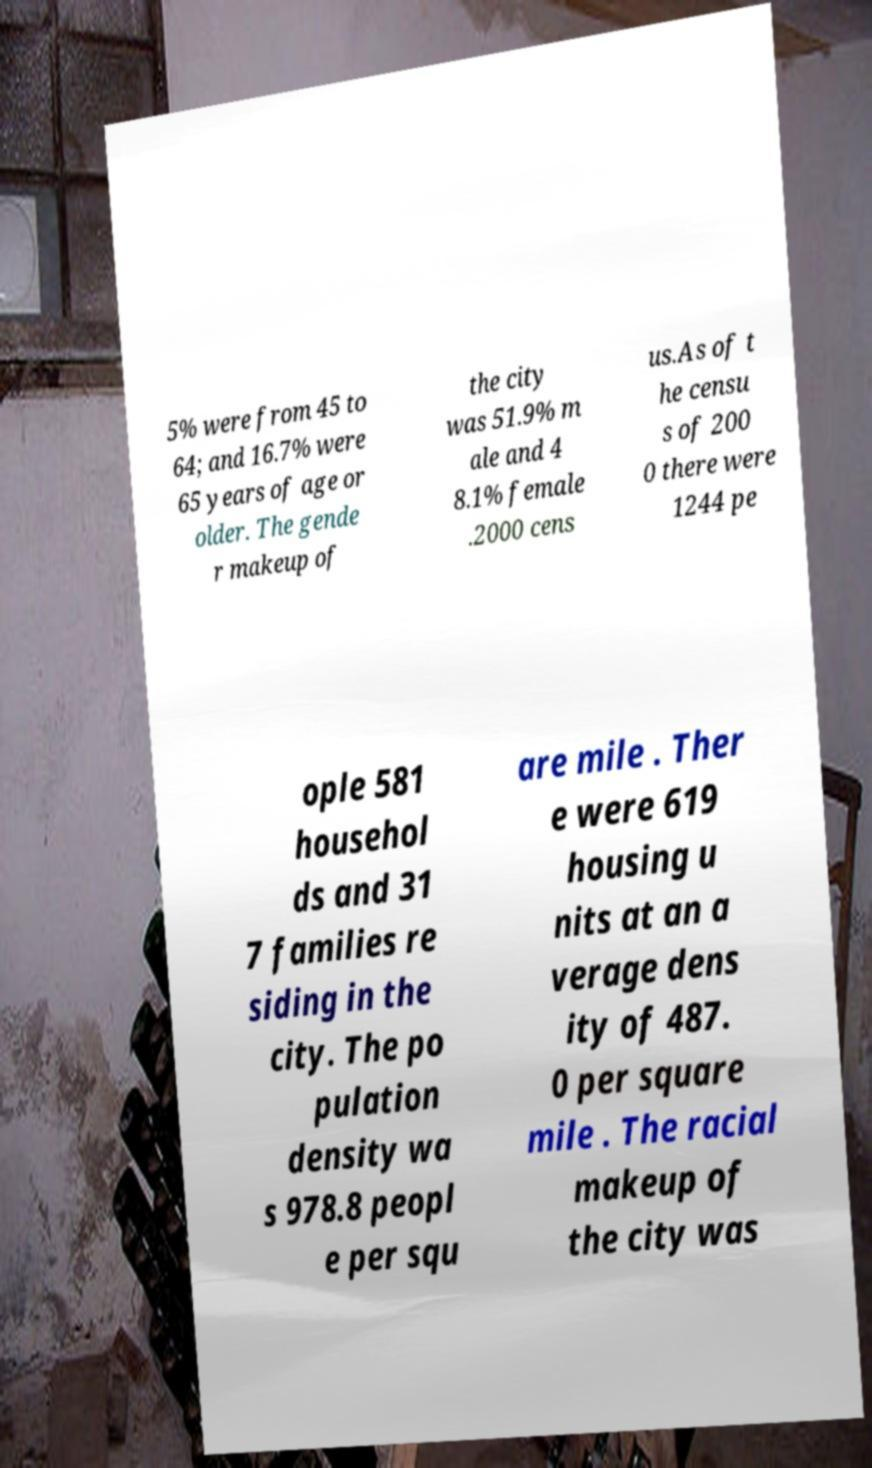Could you assist in decoding the text presented in this image and type it out clearly? 5% were from 45 to 64; and 16.7% were 65 years of age or older. The gende r makeup of the city was 51.9% m ale and 4 8.1% female .2000 cens us.As of t he censu s of 200 0 there were 1244 pe ople 581 househol ds and 31 7 families re siding in the city. The po pulation density wa s 978.8 peopl e per squ are mile . Ther e were 619 housing u nits at an a verage dens ity of 487. 0 per square mile . The racial makeup of the city was 